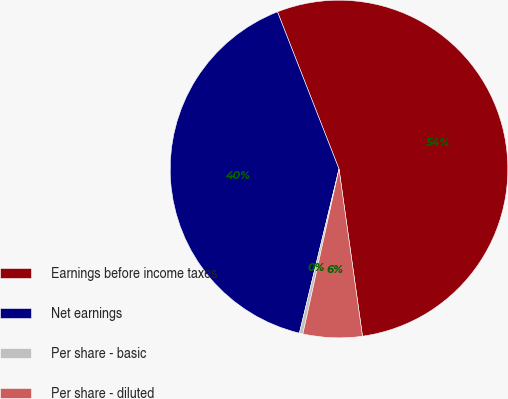<chart> <loc_0><loc_0><loc_500><loc_500><pie_chart><fcel>Earnings before income taxes<fcel>Net earnings<fcel>Per share - basic<fcel>Per share - diluted<nl><fcel>53.72%<fcel>40.29%<fcel>0.34%<fcel>5.65%<nl></chart> 